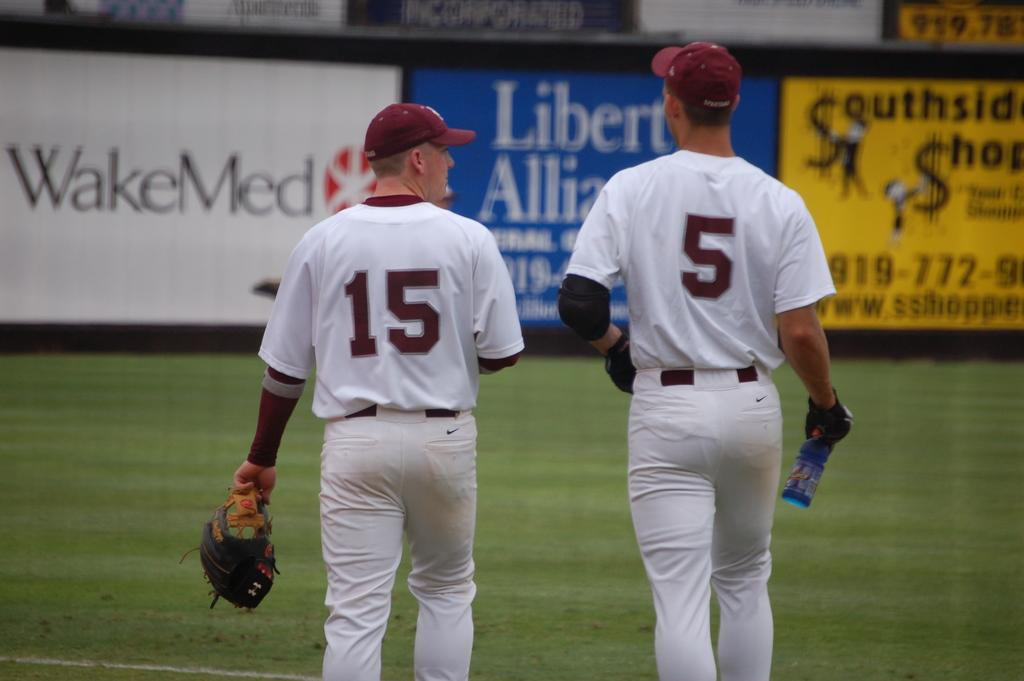<image>
Provide a brief description of the given image. a couple players that have the numbers 15 and 5 on it 